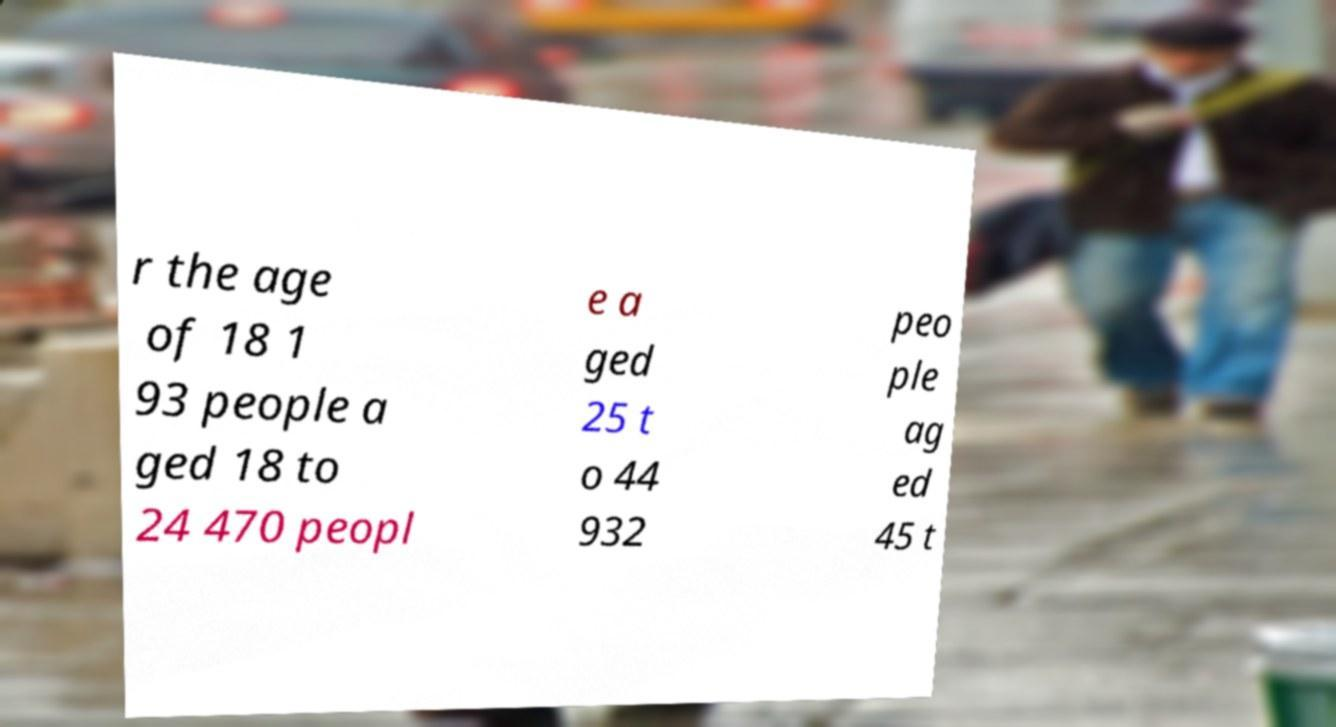Please read and relay the text visible in this image. What does it say? r the age of 18 1 93 people a ged 18 to 24 470 peopl e a ged 25 t o 44 932 peo ple ag ed 45 t 